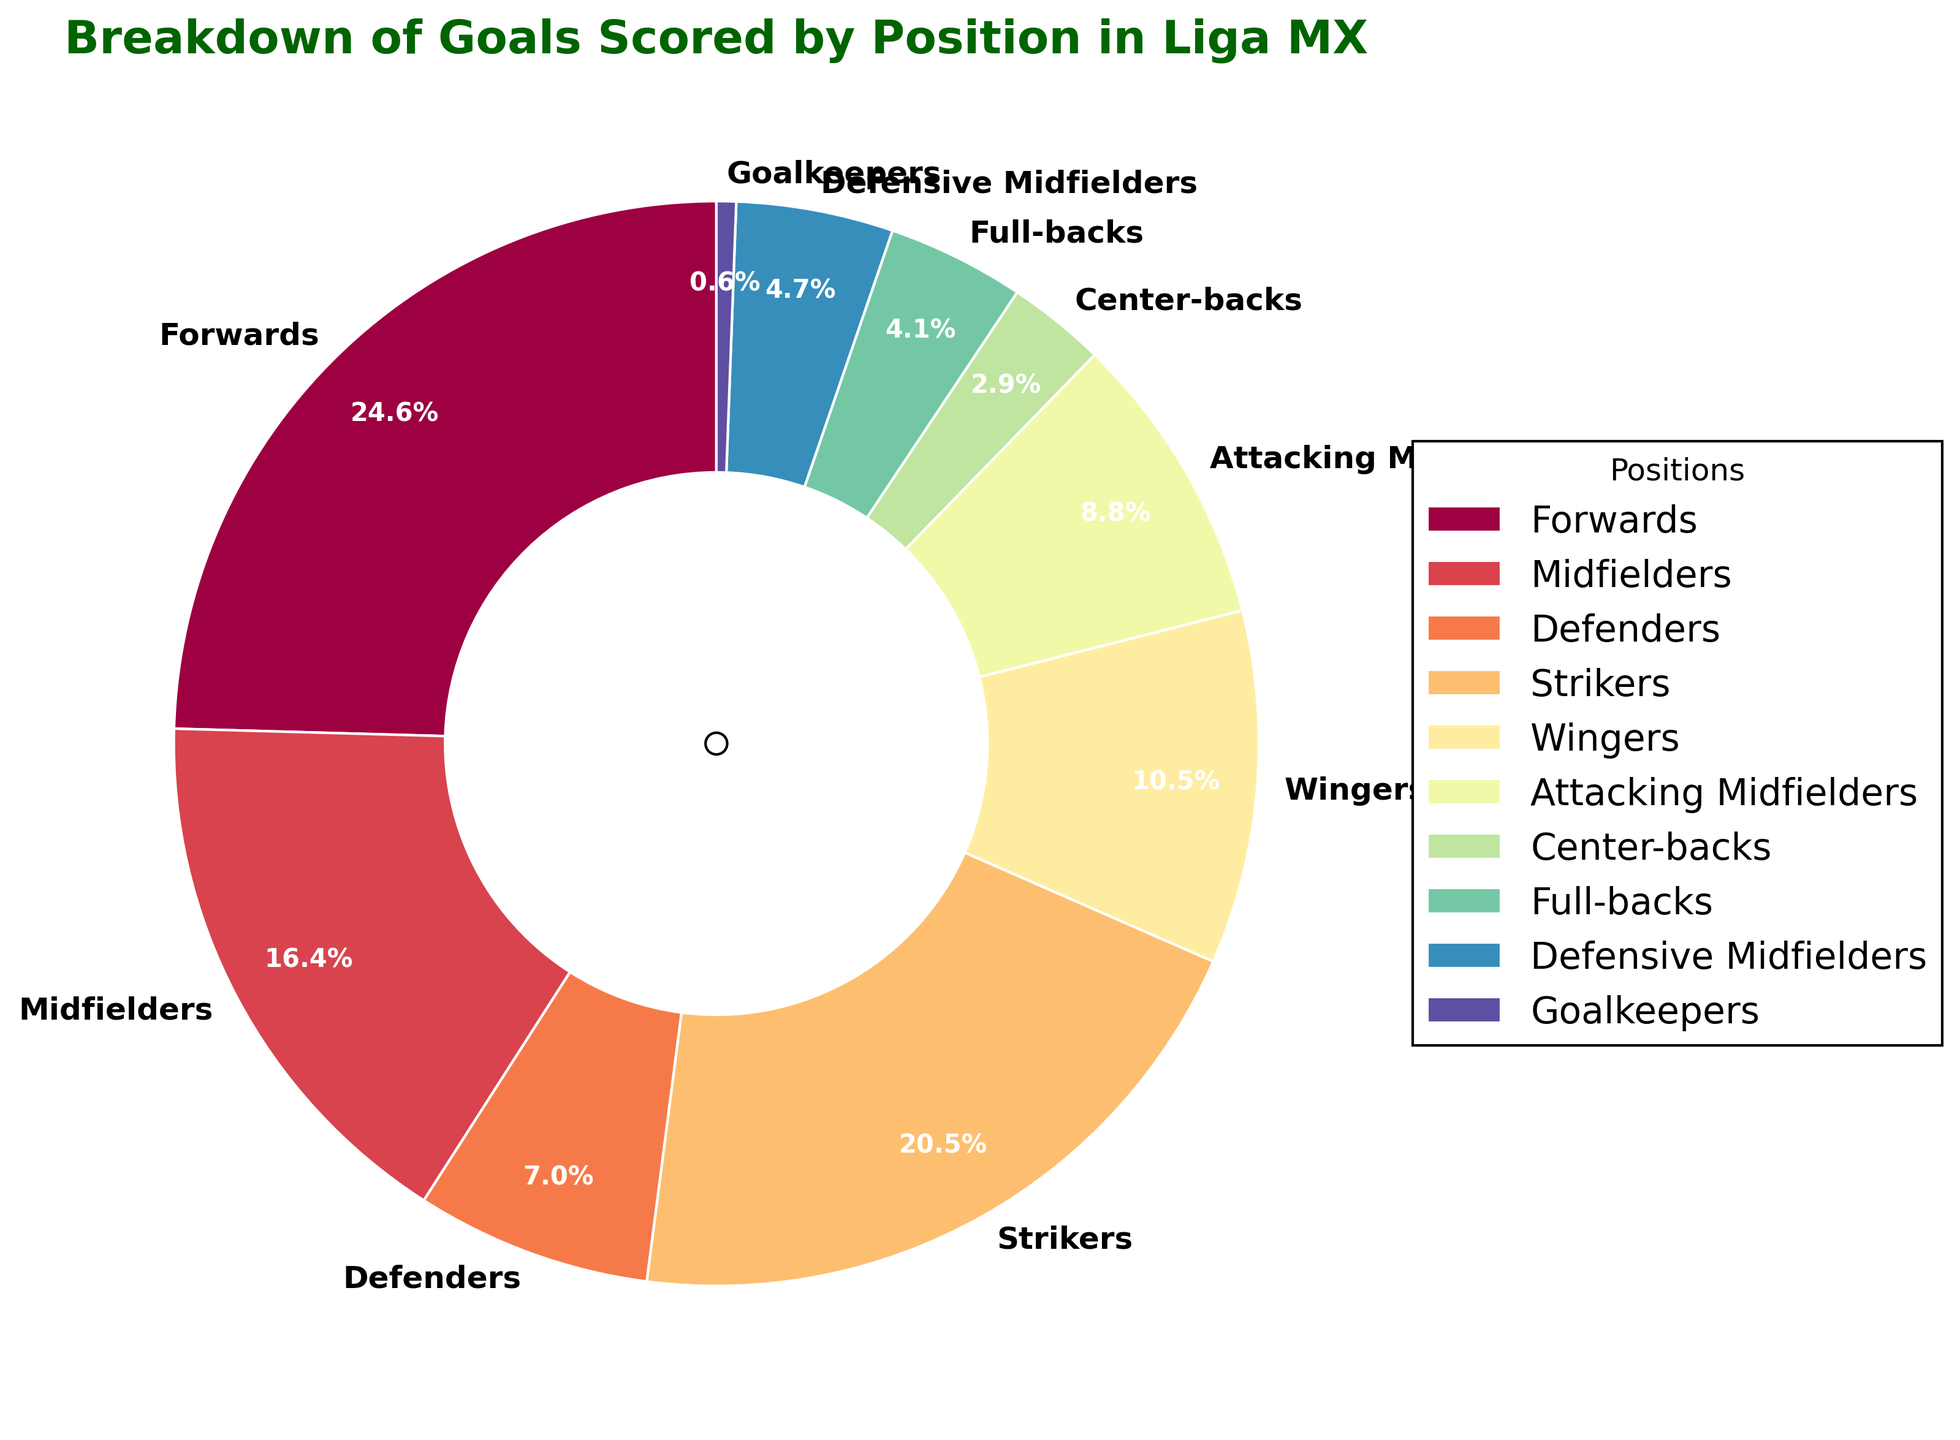Which position scored the highest number of goals? Look at the pie chart and identify the wedge with the largest proportion. The forward wedge has the largest section.
Answer: Forwards How many goals did midfielders and wingers score combined? Sum the goals scored by midfielders (28) and wingers (18). The total is 28 + 18 = 46.
Answer: 46 Which position scored fewer goals, center-backs or goalkeepers? Compare the size of the wedges for center-backs and goalkeepers. The goalkeeper wedge is smaller.
Answer: Goalkeepers By how many goals do strikers outperform defensive midfielders? Subtract the goals of defensive midfielders (8) from the goals of strikers (35). The difference is 35 - 8 = 27.
Answer: 27 What percentage of the total goals were scored by full-backs? Reference the pie chart to find the percentage label for full-backs: it is 7 out of the total goals. Since percentages are already provided in the pie chart, you can directly see the result.
Answer: 7% Which two positions together scored more goals, forwards and defenders or strikers and goalkeepers? Sum the goals for each pair separately: Forwards (42) + Defenders (12) = 54; Strikers (35) + Goalkeepers (1) = 36. Compare the two sums; 54 > 36.
Answer: Forwards and Defenders What is the visual color assigned to attacking midfielders in the pie chart? Look at the attacking midfielders wedge in the pie chart. Identify its color based on the visual observation.
Answer: (Color based on visual, e.g., "Light Blue") What's the total number of goals scored by defensive and attacking midfielders? Sum the goals for defensive midfielders (8) and attacking midfielders (15). The total is 8 + 15 = 23.
Answer: 23 Which position scored exactly 1 goal? Identify the smallest wedge in the pie chart, which represents goalkeepers.
Answer: Goalkeepers 